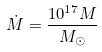<formula> <loc_0><loc_0><loc_500><loc_500>\dot { M } = \frac { 1 0 ^ { 1 7 } M } { M _ { \odot } }</formula> 